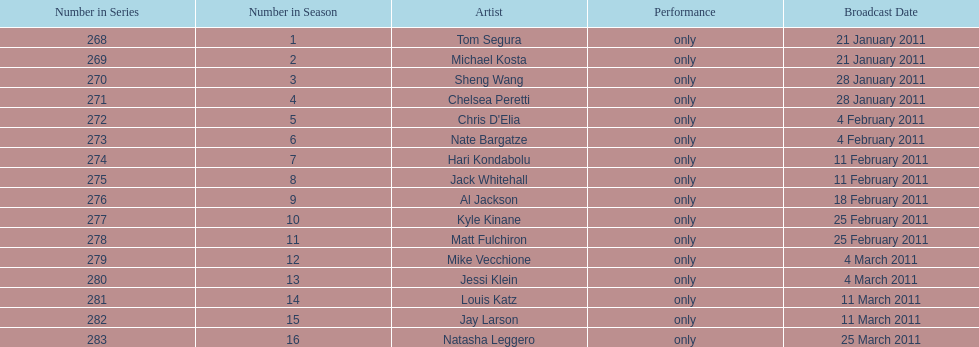How many weeks did season 15 of comedy central presents span? 9. 